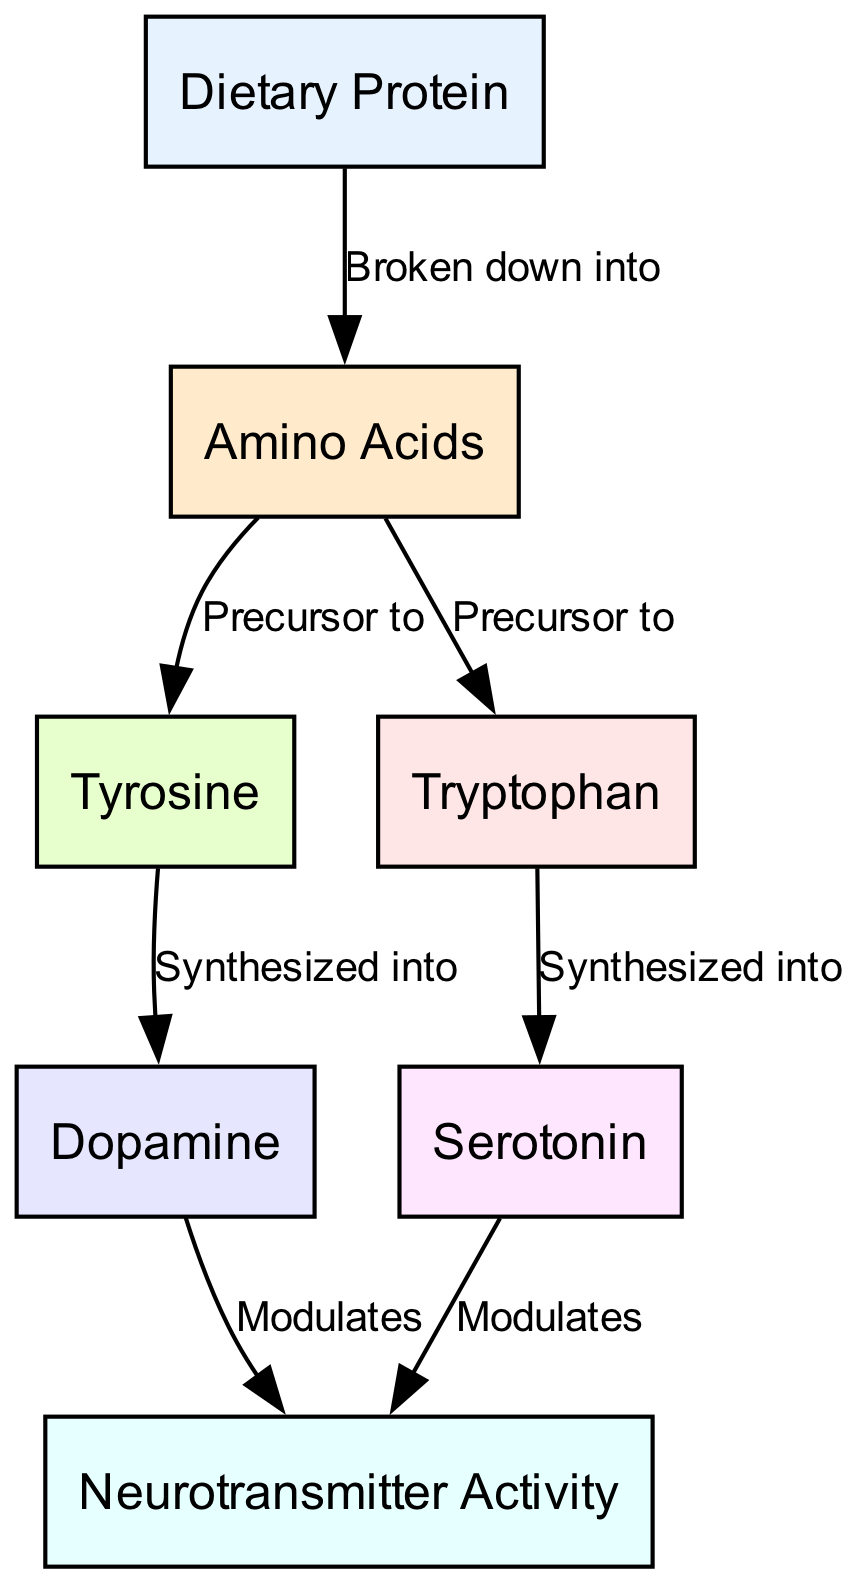What are the two amino acids derived from dietary protein? The diagram shows that dietary protein is broken down into amino acids. The nodes for amino acids identify two specific precursors: Tyrosine and Tryptophan.
Answer: Tyrosine and Tryptophan How many total nodes are present in the diagram? By counting the listed nodes, we find there are 7 distinct entities: Dietary Protein, Amino Acids, Tyrosine, Tryptophan, Dopamine, Serotonin, and Neurotransmitter Activity.
Answer: 7 What neurotransmitter is synthesized from Tyrosine? The diagram specifies that Tyrosine is synthesized into Dopamine, which is represented by the direct edge connection in the diagram.
Answer: Dopamine Which two neurotransmitters modulate neurotransmitter activity? The diagram indicates that both Dopamine and Serotonin modulate Neurotransmitter Activity, as shown in the connections leading from these neurotransmitters to the activity node.
Answer: Dopamine and Serotonin What is the relationship between Amino Acids and Tyrosine? The edge in the graph states that Amino Acids are the precursor to Tyrosine. This establishes a direct flow of influence from amino acids leading to the synthesis of Tyrosine.
Answer: Precursor to Which neurotransmitter is synthesized from Tryptophan? The diagram clearly indicates that Tryptophan is synthesized into Serotonin, which is demonstrated by the edge connecting these two nodes.
Answer: Serotonin How many edges are there in the diagram? By reviewing the relationships outlined in the diagram, we can count a total of 6 edges that connect the various nodes, representing the relationships and processes.
Answer: 6 What influences the Neurotransmitter Activity according to the diagram? The edges indicate that both Dopamine and Serotonin influence Neurotransmitter Activity, with each neurotransmitter having a direct influence on the activity.
Answer: Dopamine and Serotonin 